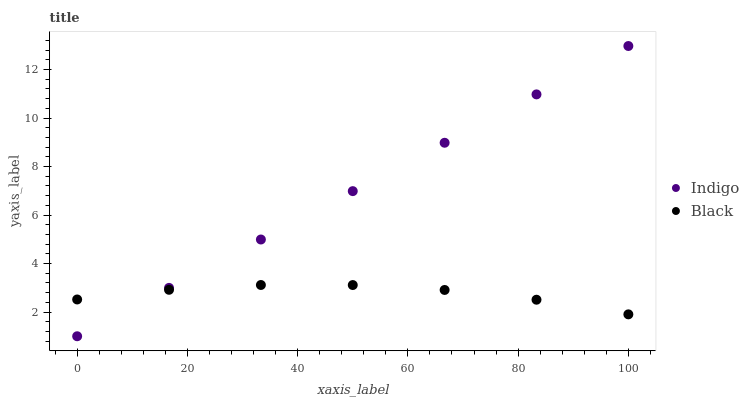Does Black have the minimum area under the curve?
Answer yes or no. Yes. Does Indigo have the maximum area under the curve?
Answer yes or no. Yes. Does Indigo have the minimum area under the curve?
Answer yes or no. No. Is Indigo the smoothest?
Answer yes or no. Yes. Is Black the roughest?
Answer yes or no. Yes. Is Indigo the roughest?
Answer yes or no. No. Does Indigo have the lowest value?
Answer yes or no. Yes. Does Indigo have the highest value?
Answer yes or no. Yes. Does Black intersect Indigo?
Answer yes or no. Yes. Is Black less than Indigo?
Answer yes or no. No. Is Black greater than Indigo?
Answer yes or no. No. 